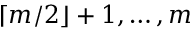Convert formula to latex. <formula><loc_0><loc_0><loc_500><loc_500>\lceil m / 2 \rfloor + 1 , \dots , m</formula> 